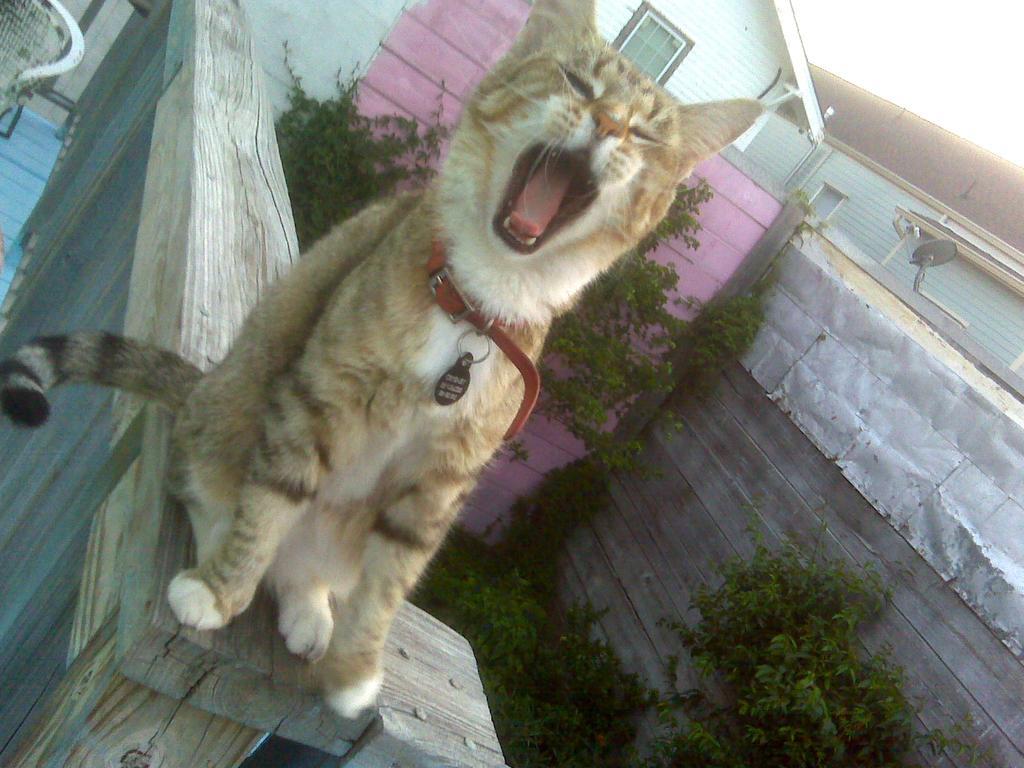Describe this image in one or two sentences. In the picture I can see a cat which is sitting on a wooden object and there is a chair in the left corner and there are trees and buildings in the right corner. 